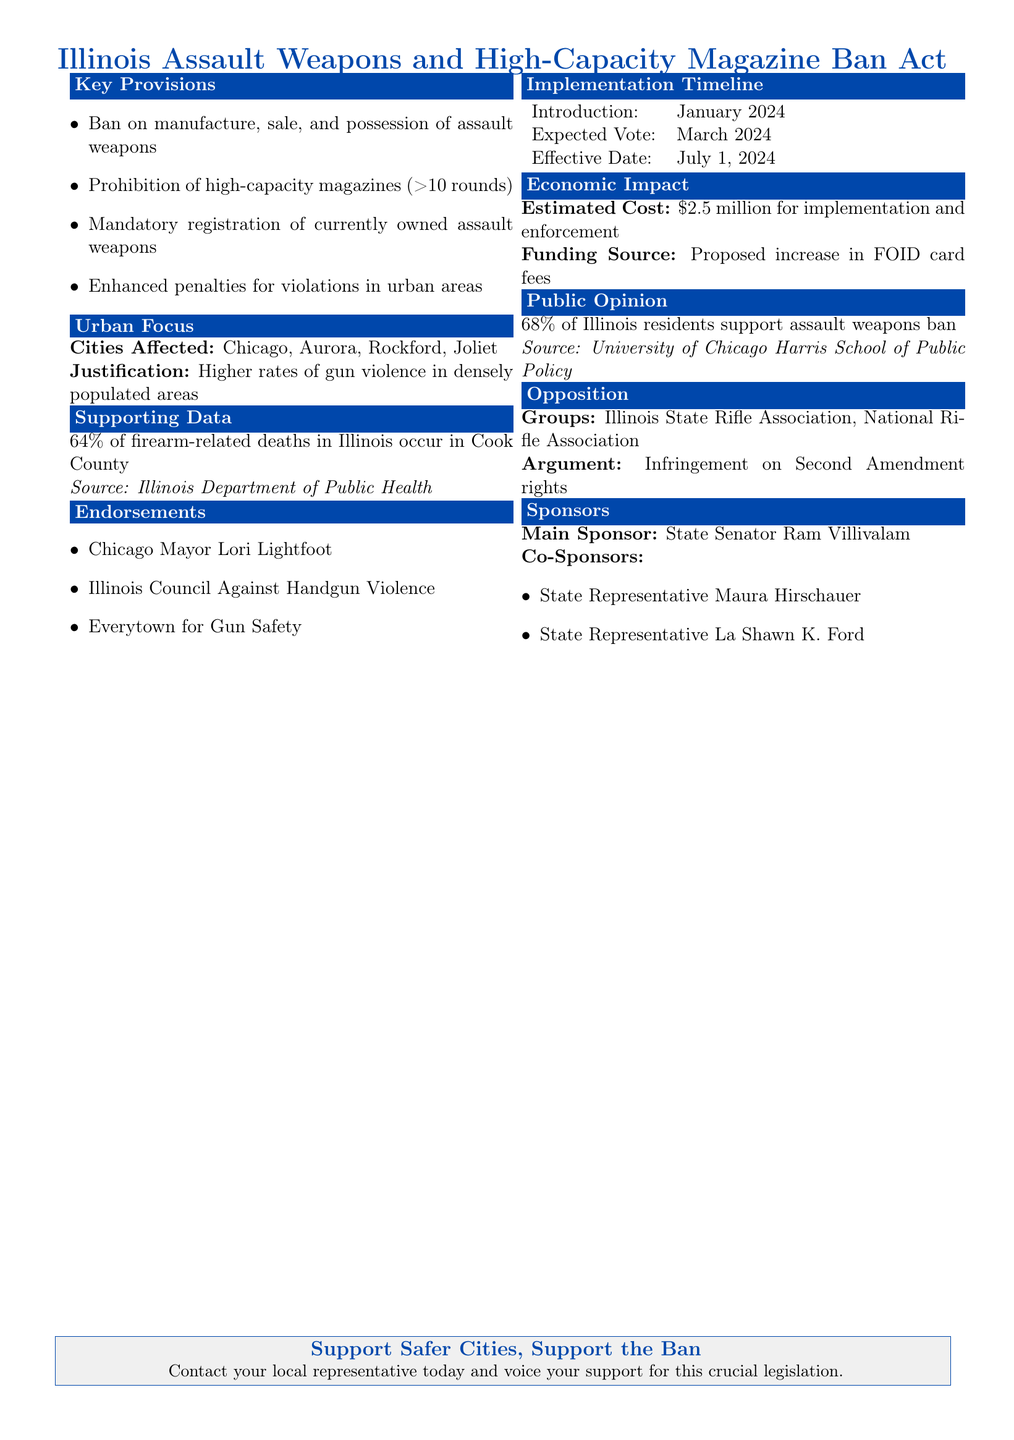What is the main focus of the legislation? The legislation primarily focuses on banning assault weapons and high-capacity magazines in Illinois urban areas.
Answer: Assault weapons and high-capacity magazines What percentage of firearm-related deaths occur in Cook County? The document states that a significant percentage of firearm-related deaths occur in Cook County, providing data.
Answer: 64% When is the effective date of the legislation? The legislation outlines a timeline, specifying when it will take effect.
Answer: July 1, 2024 Who is the main sponsor of the bill? The document lists the key individuals involved in sponsoring the legislation for clarity.
Answer: State Senator Ram Villivalam What is the estimated cost for implementation and enforcement? The document provides financial information regarding the estimated costs associated with the ban.
Answer: $2.5 million Which city is mentioned as having higher rates of gun violence? The document references specific cities that are primarily affected by the legislation.
Answer: Chicago What is the public support rate for the assault weapon ban? The document includes a statistic that reflects the public opinion on the proposed legislation.
Answer: 68% What justification is given for focusing on urban areas in the legislation? The document explains the reasoning behind the legislative focus on urban environments.
Answer: Higher rates of gun violence Which group opposes the proposed legislation? The document cites specific organizations that are against the legislation.
Answer: Illinois State Rifle Association 